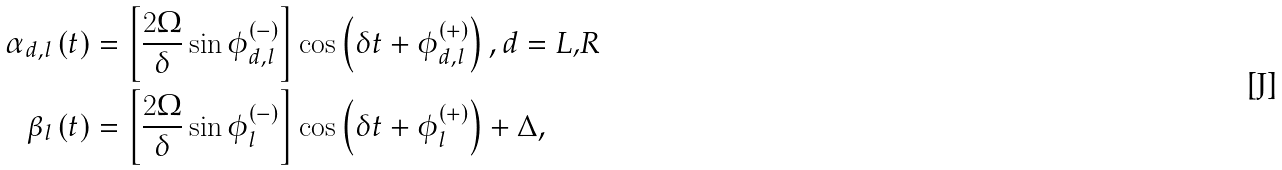<formula> <loc_0><loc_0><loc_500><loc_500>\alpha _ { d , l } \left ( t \right ) & = \left [ \frac { 2 \Omega } { \delta } \sin \phi _ { d , l } ^ { \left ( - \right ) } \right ] \cos \left ( \delta t + \phi _ { d , l } ^ { \left ( + \right ) } \right ) , d = \text {L,R} \\ \beta _ { l } \left ( t \right ) & = \left [ \frac { 2 \Omega } { \delta } \sin \phi _ { l } ^ { \left ( - \right ) } \right ] \cos \left ( \delta t + \phi _ { l } ^ { \left ( + \right ) } \right ) + \Delta ,</formula> 